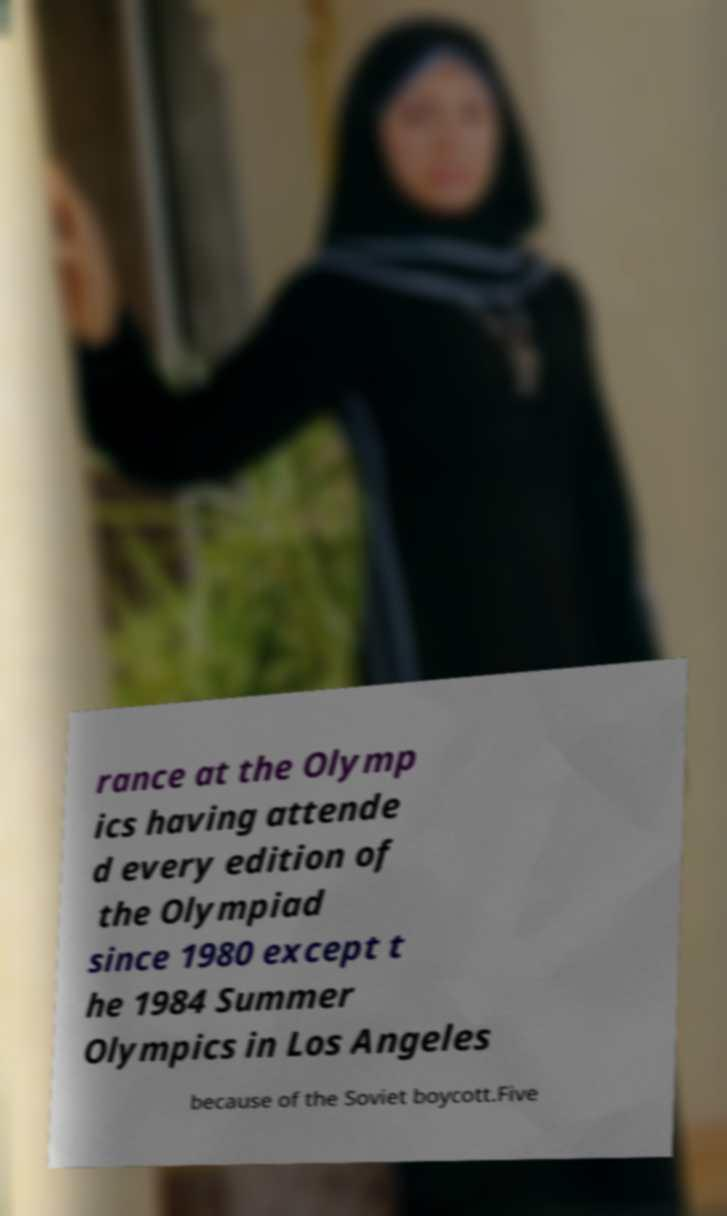There's text embedded in this image that I need extracted. Can you transcribe it verbatim? rance at the Olymp ics having attende d every edition of the Olympiad since 1980 except t he 1984 Summer Olympics in Los Angeles because of the Soviet boycott.Five 